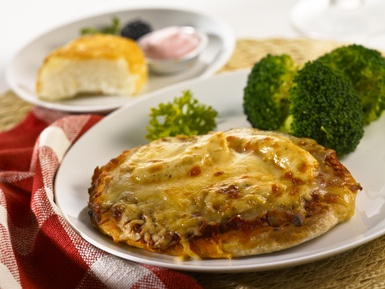Describe the objects in this image and their specific colors. I can see sandwich in white, olive, maroon, tan, and orange tones, broccoli in white, darkgreen, and olive tones, sandwich in white, tan, and orange tones, dining table in ivory, beige, and white tones, and broccoli in white, olive, tan, and beige tones in this image. 